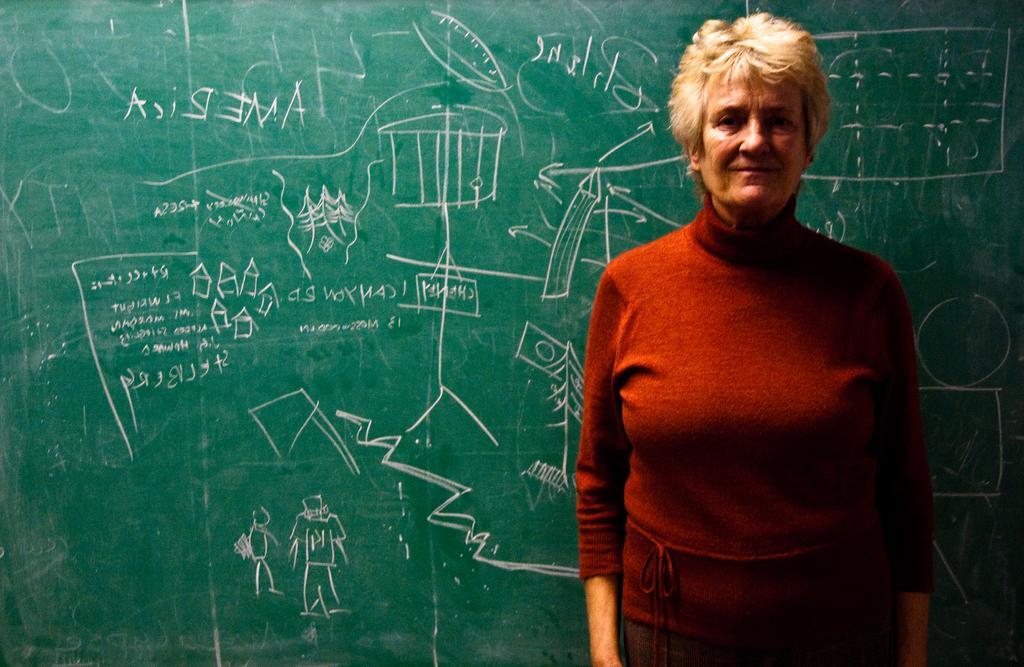How would you summarize this image in a sentence or two? In this image I see a woman who is wearing red top and I see that she is standing. In the background I see the green board on which there are is something written. 